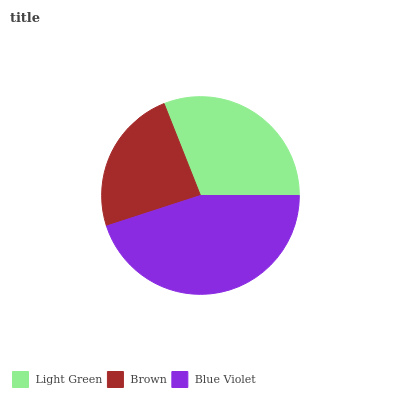Is Brown the minimum?
Answer yes or no. Yes. Is Blue Violet the maximum?
Answer yes or no. Yes. Is Blue Violet the minimum?
Answer yes or no. No. Is Brown the maximum?
Answer yes or no. No. Is Blue Violet greater than Brown?
Answer yes or no. Yes. Is Brown less than Blue Violet?
Answer yes or no. Yes. Is Brown greater than Blue Violet?
Answer yes or no. No. Is Blue Violet less than Brown?
Answer yes or no. No. Is Light Green the high median?
Answer yes or no. Yes. Is Light Green the low median?
Answer yes or no. Yes. Is Blue Violet the high median?
Answer yes or no. No. Is Brown the low median?
Answer yes or no. No. 